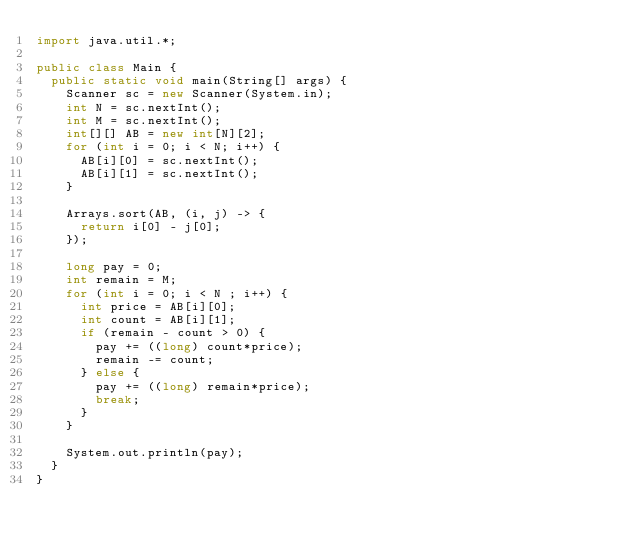Convert code to text. <code><loc_0><loc_0><loc_500><loc_500><_Java_>import java.util.*;

public class Main {
  public static void main(String[] args) {
    Scanner sc = new Scanner(System.in);
    int N = sc.nextInt();
    int M = sc.nextInt();
    int[][] AB = new int[N][2];
    for (int i = 0; i < N; i++) {
      AB[i][0] = sc.nextInt();
      AB[i][1] = sc.nextInt();
    }
    
    Arrays.sort(AB, (i, j) -> {
      return i[0] - j[0];
    });
    
    long pay = 0;
    int remain = M;
    for (int i = 0; i < N ; i++) {
      int price = AB[i][0];
      int count = AB[i][1];
      if (remain - count > 0) {
        pay += ((long) count*price);
        remain -= count;
      } else {
        pay += ((long) remain*price);
        break;
      }
    }

    System.out.println(pay);
  }
}</code> 